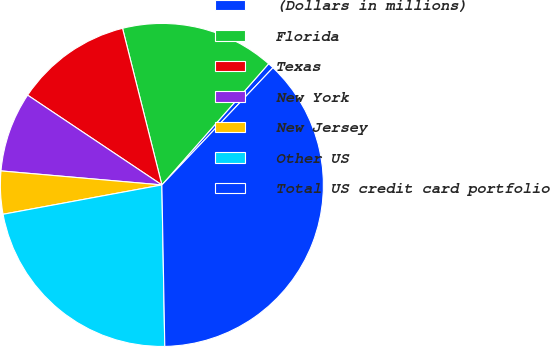Convert chart to OTSL. <chart><loc_0><loc_0><loc_500><loc_500><pie_chart><fcel>(Dollars in millions)<fcel>Florida<fcel>Texas<fcel>New York<fcel>New Jersey<fcel>Other US<fcel>Total US credit card portfolio<nl><fcel>0.58%<fcel>15.41%<fcel>11.7%<fcel>8.0%<fcel>4.29%<fcel>22.38%<fcel>37.64%<nl></chart> 